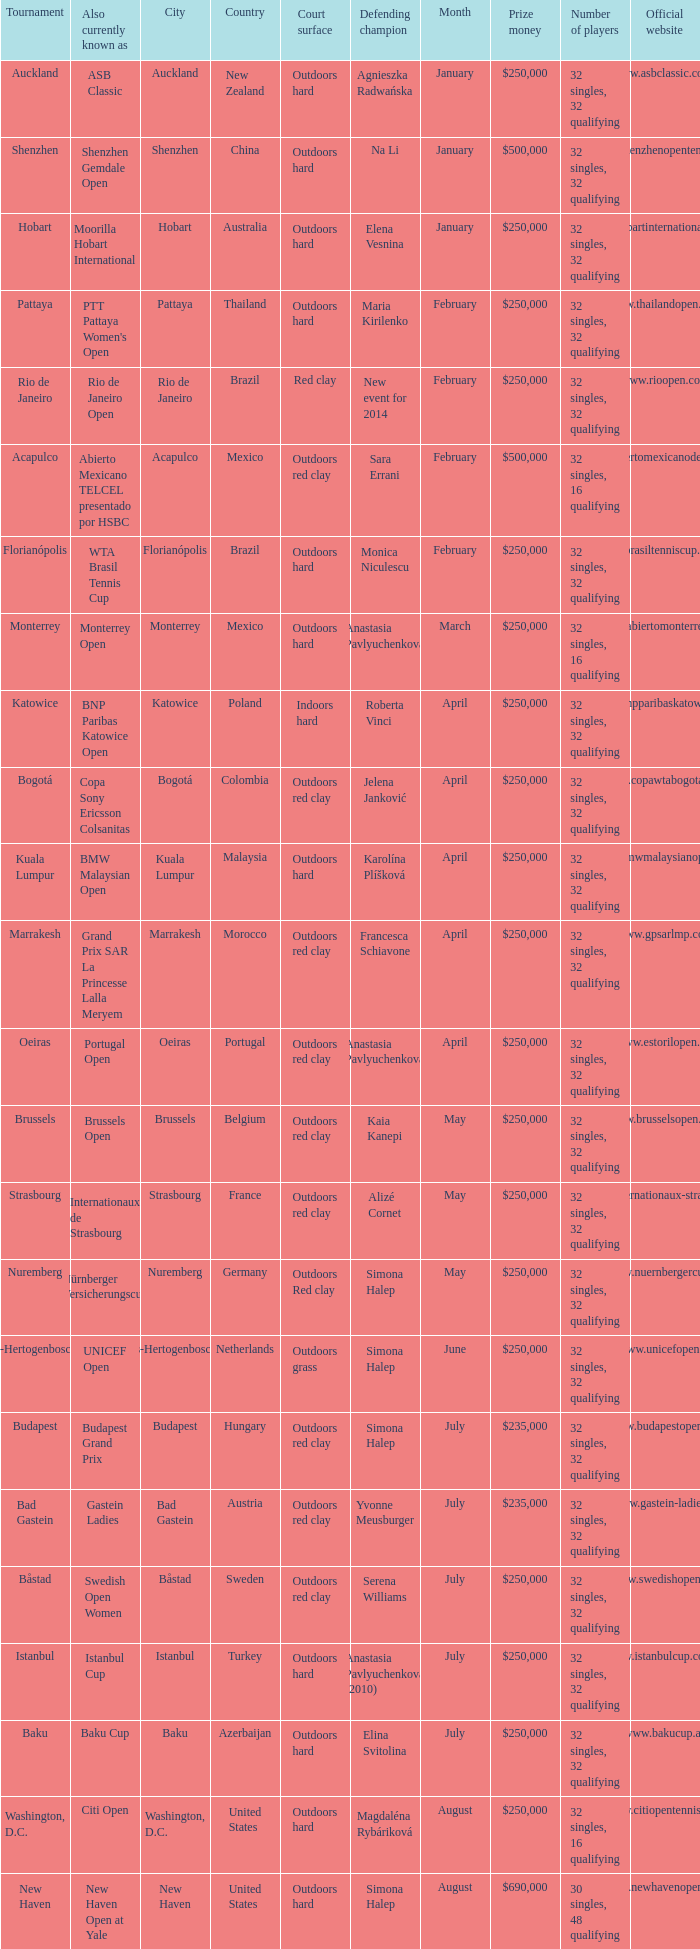How many tournaments are also currently known as the hp open? 1.0. 